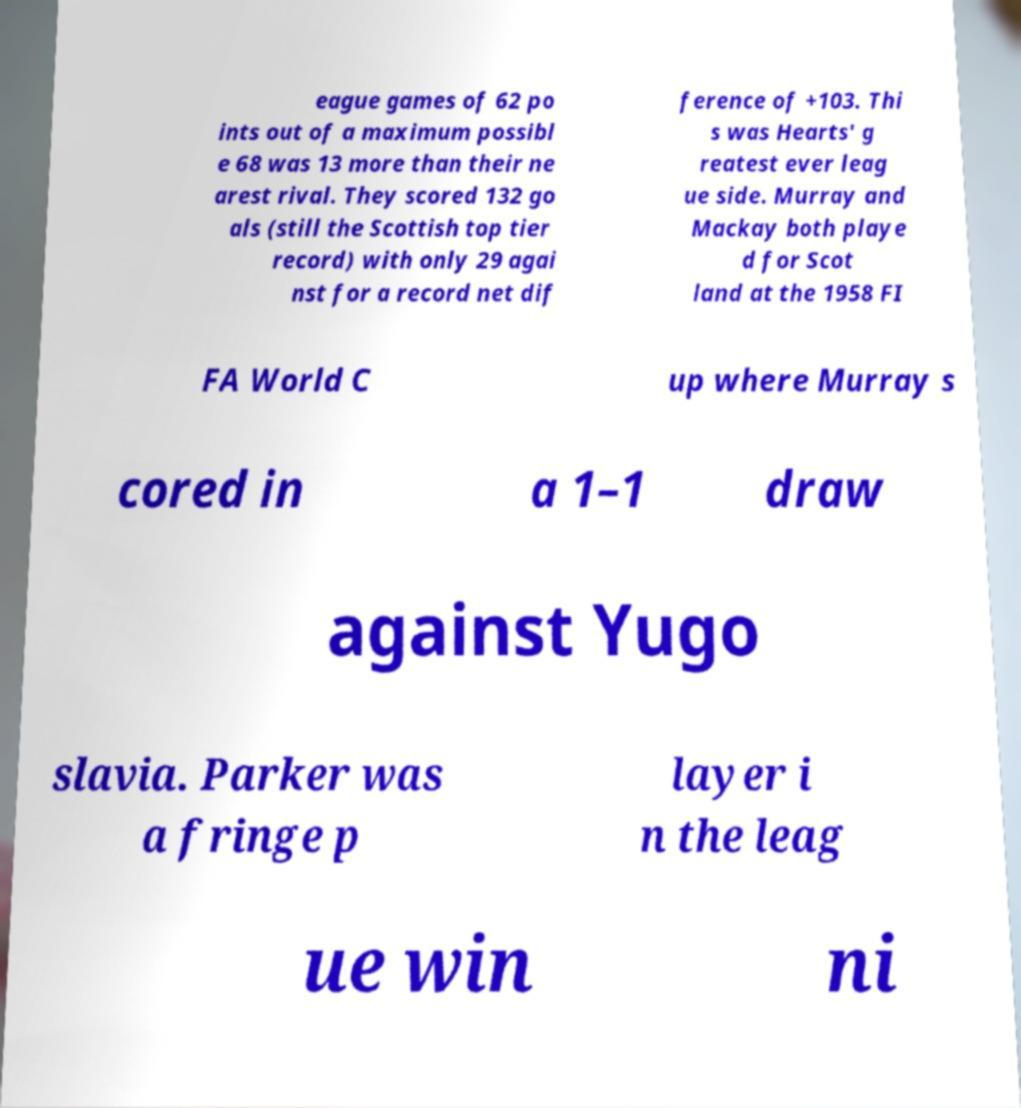I need the written content from this picture converted into text. Can you do that? eague games of 62 po ints out of a maximum possibl e 68 was 13 more than their ne arest rival. They scored 132 go als (still the Scottish top tier record) with only 29 agai nst for a record net dif ference of +103. Thi s was Hearts' g reatest ever leag ue side. Murray and Mackay both playe d for Scot land at the 1958 FI FA World C up where Murray s cored in a 1–1 draw against Yugo slavia. Parker was a fringe p layer i n the leag ue win ni 